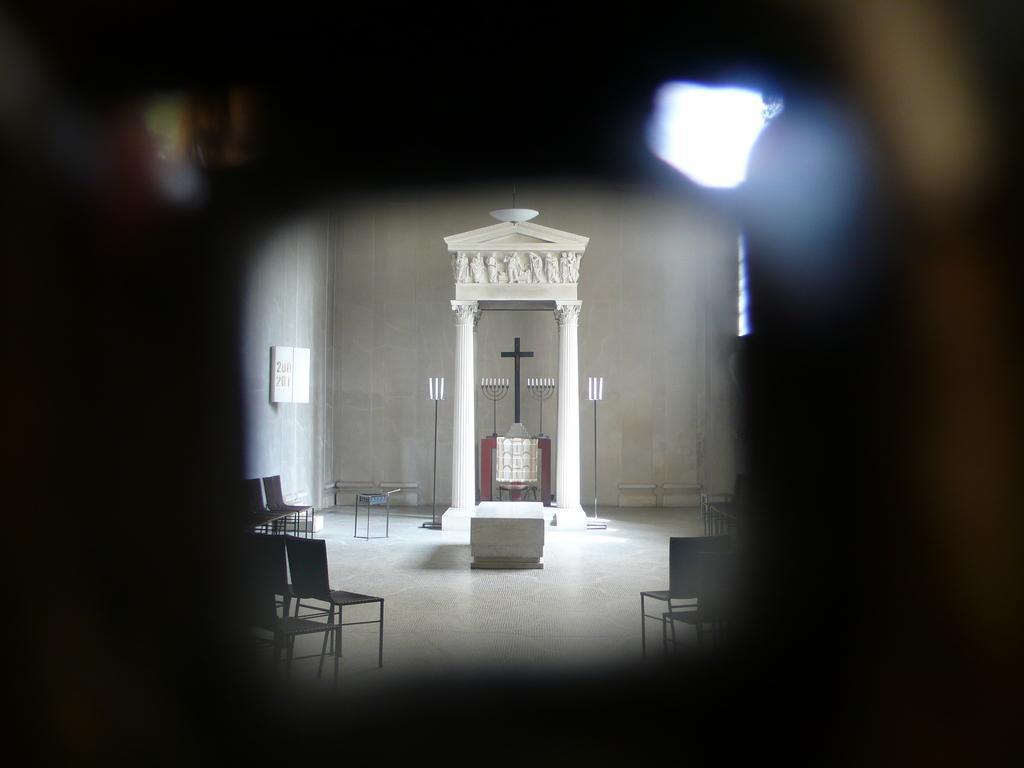Could you give a brief overview of what you see in this image? In this image, we can see an arch and in the background, there are chairs and lights. 